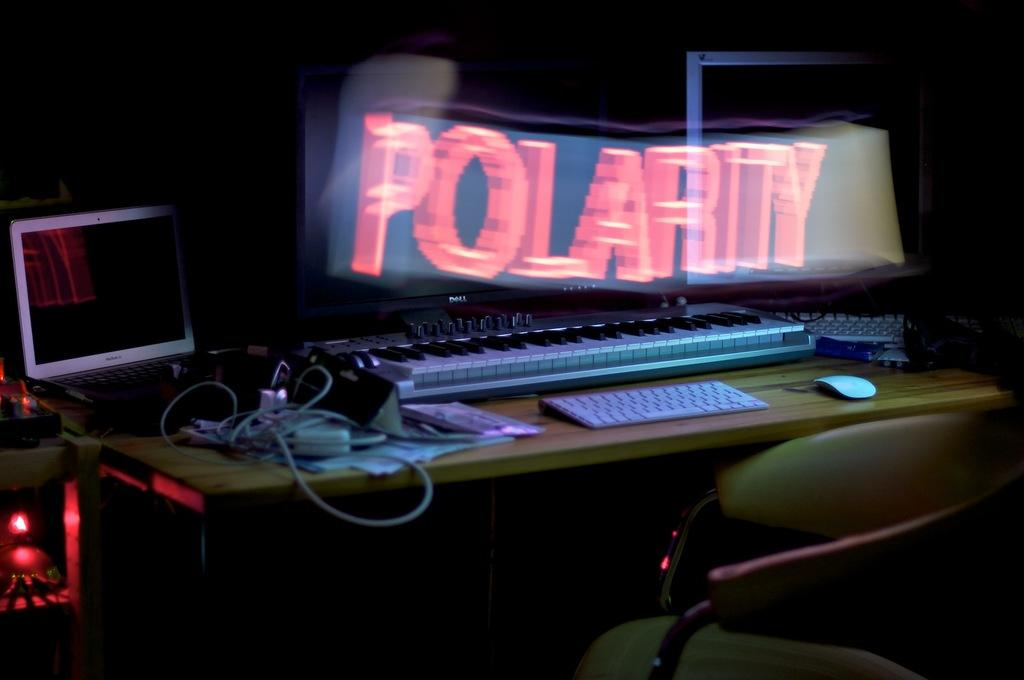What type of input device is visible in the image? There is a keyboard and a computer mouse in the image. What type of computing device is present in the image? There is a laptop in the image. What musical instrument can be seen in the image? There is a musical instrument in the image. What other objects are on the table in the image? There are other objects on the table, but their specific details are not mentioned in the provided facts. What piece of furniture is on the right side of the image? There is a chair on the right side of the image. What type of record is being played on the turntable in the image? There is no turntable or record present in the image. What team is responsible for organizing the event in the image? There is no event or team mentioned in the provided facts. 